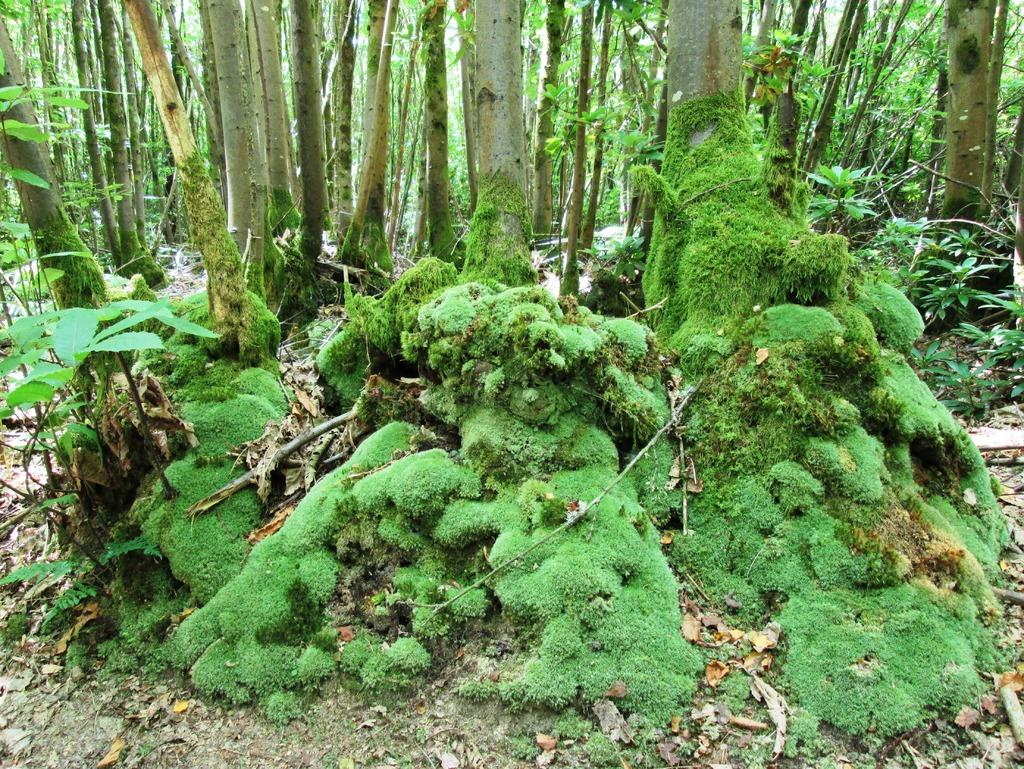What type of environment might the image be taken from? The image might be taken from a forest. What type of vegetation can be seen in the image? There are trees in the image. What type of ground cover is visible at the bottom of the image? There is grass visible at the bottom of the image. What type of terrain is visible in the image? There is land visible in the image. What type of objects can be seen on the land? There are stones present on the land. What type of jeans is the tree wearing in the image? There are no jeans present in the image, as trees do not wear clothing. 